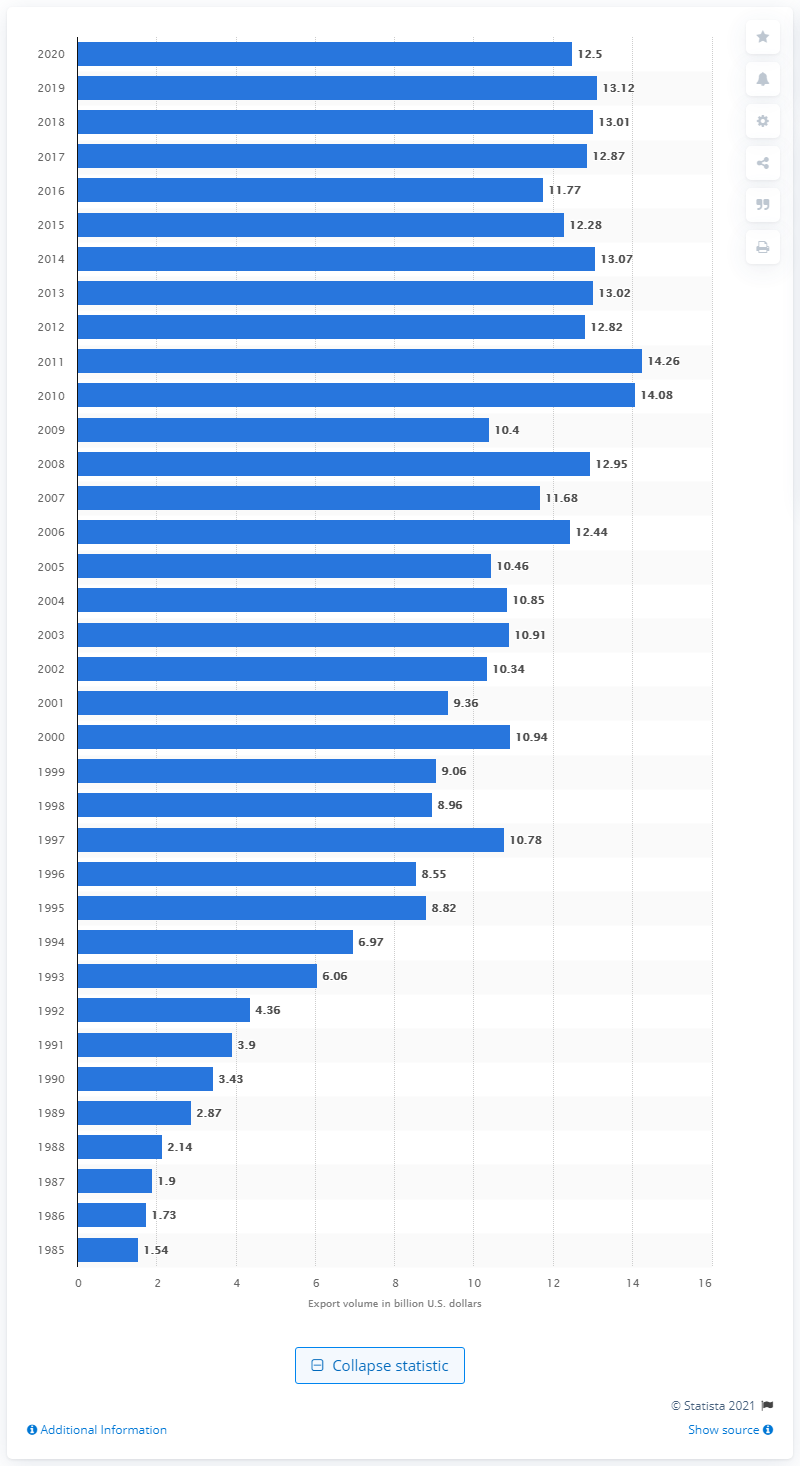Give some essential details in this illustration. The U.S. exported $12.5 billion to Malaysia in 2020. 